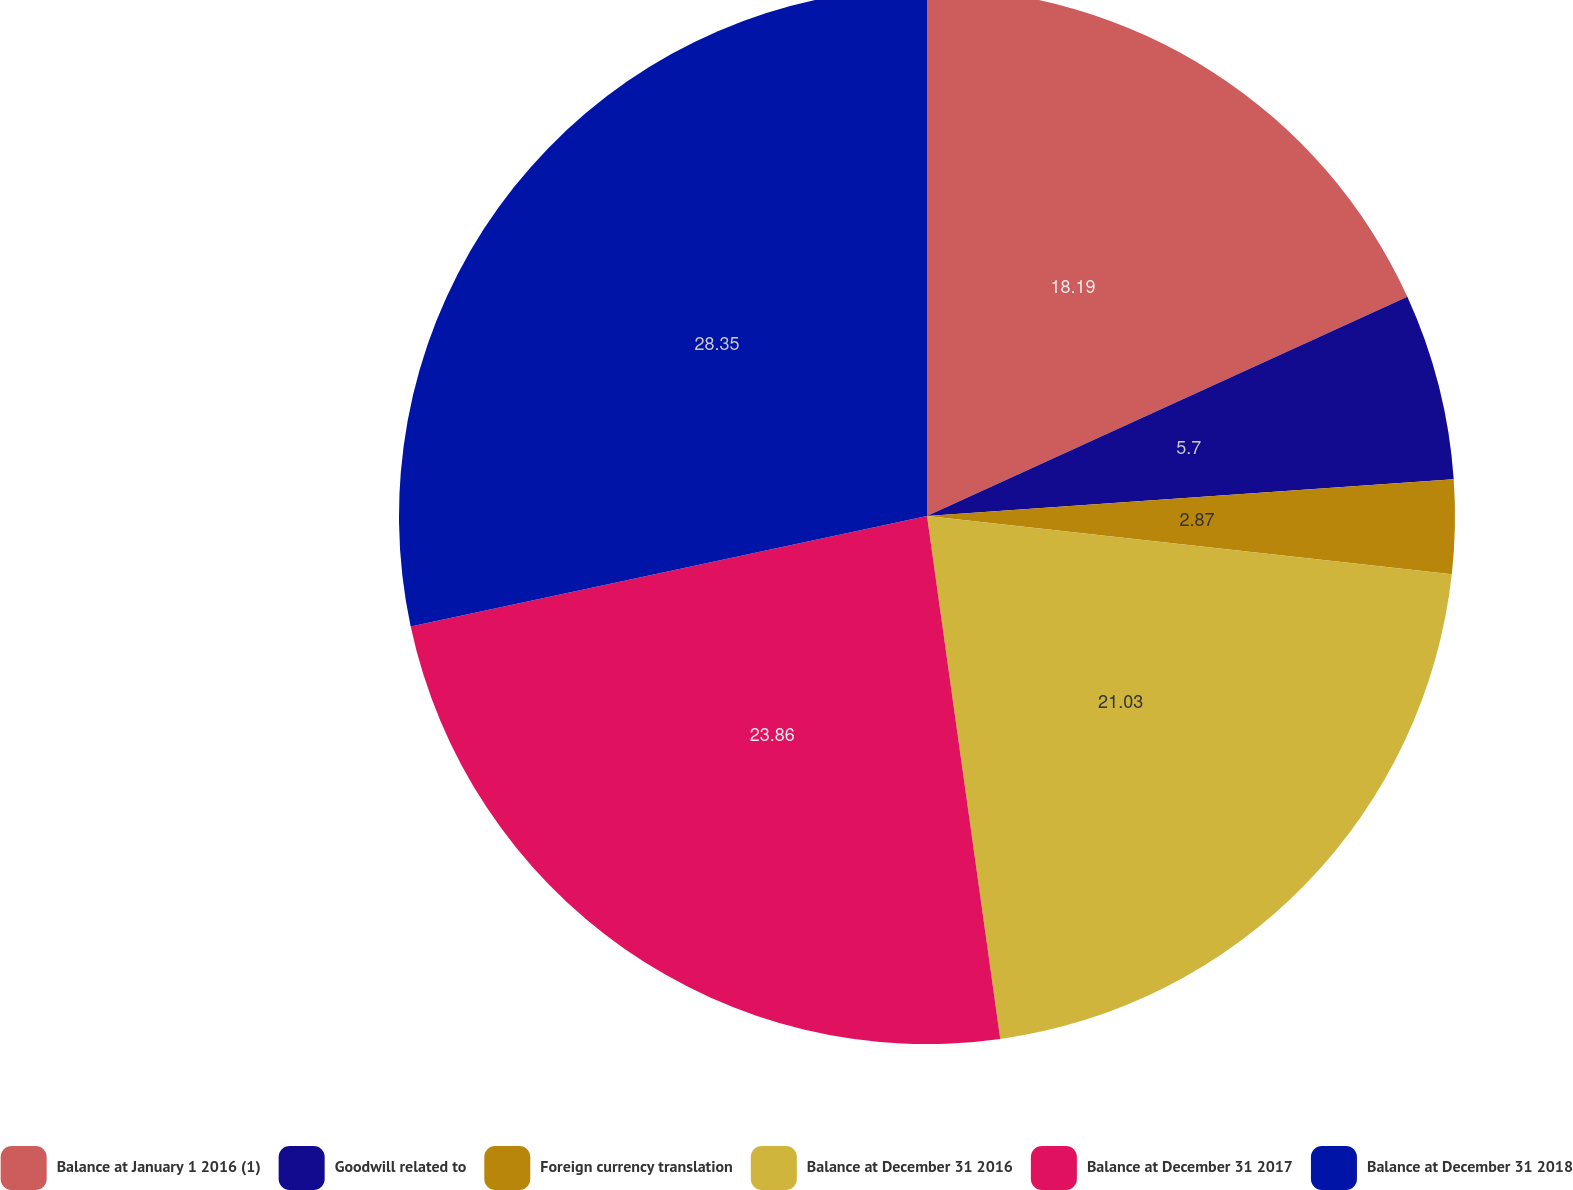Convert chart to OTSL. <chart><loc_0><loc_0><loc_500><loc_500><pie_chart><fcel>Balance at January 1 2016 (1)<fcel>Goodwill related to<fcel>Foreign currency translation<fcel>Balance at December 31 2016<fcel>Balance at December 31 2017<fcel>Balance at December 31 2018<nl><fcel>18.19%<fcel>5.7%<fcel>2.87%<fcel>21.03%<fcel>23.86%<fcel>28.36%<nl></chart> 